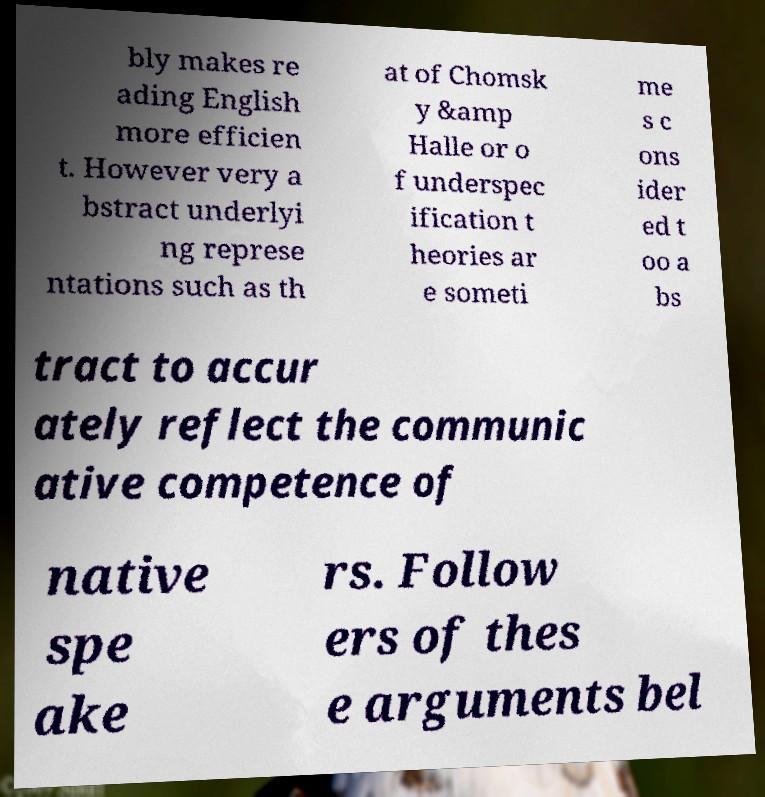I need the written content from this picture converted into text. Can you do that? bly makes re ading English more efficien t. However very a bstract underlyi ng represe ntations such as th at of Chomsk y &amp Halle or o f underspec ification t heories ar e someti me s c ons ider ed t oo a bs tract to accur ately reflect the communic ative competence of native spe ake rs. Follow ers of thes e arguments bel 